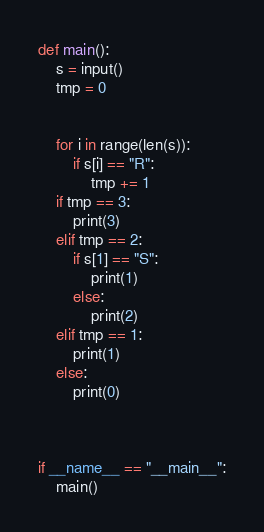<code> <loc_0><loc_0><loc_500><loc_500><_Python_>def main():
    s = input()
    tmp = 0


    for i in range(len(s)):
        if s[i] == "R":
            tmp += 1
    if tmp == 3:
        print(3)
    elif tmp == 2:
        if s[1] == "S":
            print(1)
        else:
            print(2)
    elif tmp == 1:
        print(1)
    else:
        print(0)



if __name__ == "__main__":
    main()</code> 